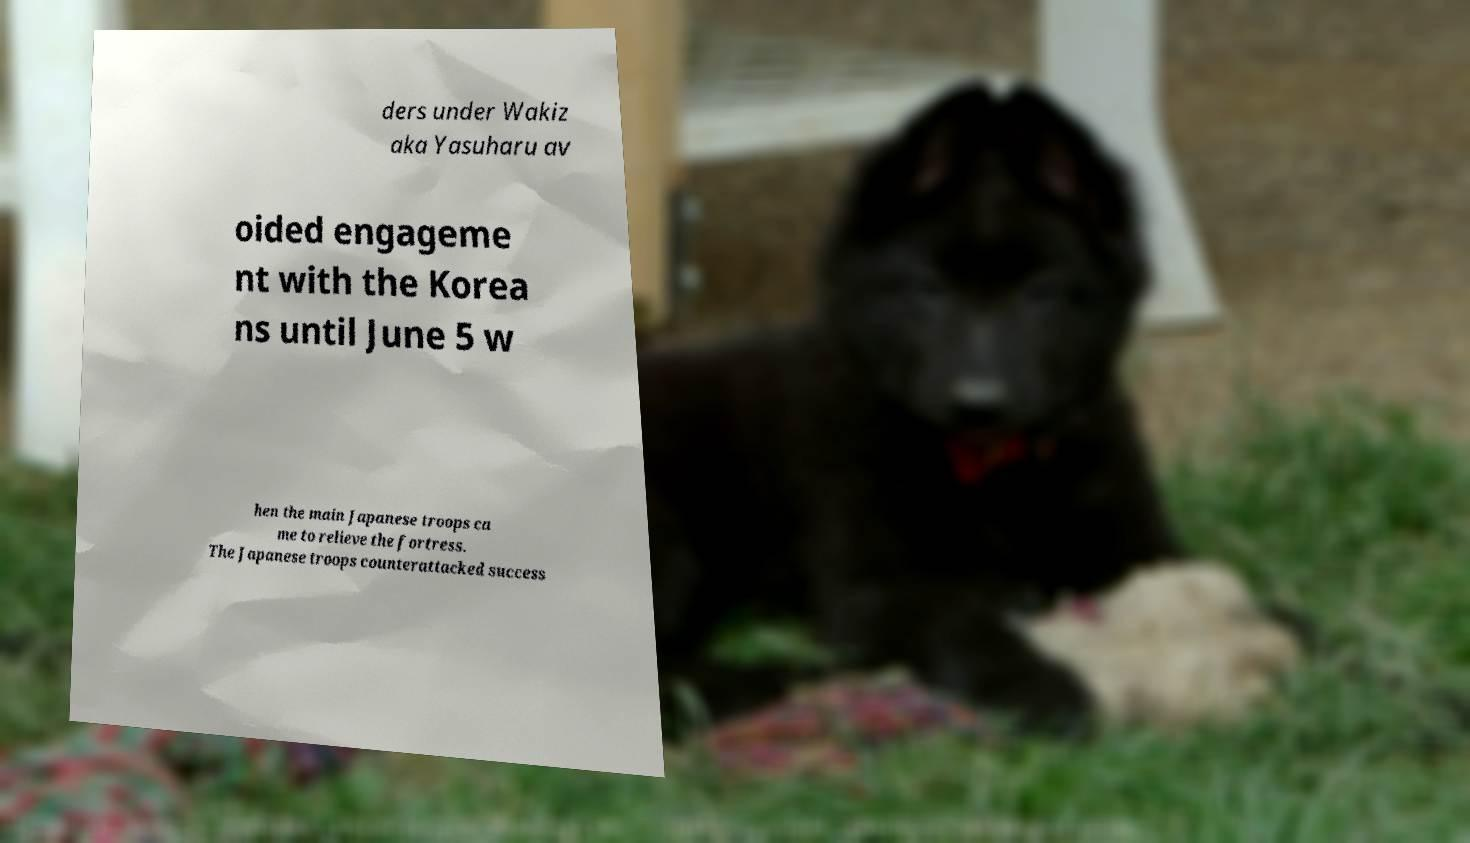For documentation purposes, I need the text within this image transcribed. Could you provide that? ders under Wakiz aka Yasuharu av oided engageme nt with the Korea ns until June 5 w hen the main Japanese troops ca me to relieve the fortress. The Japanese troops counterattacked success 